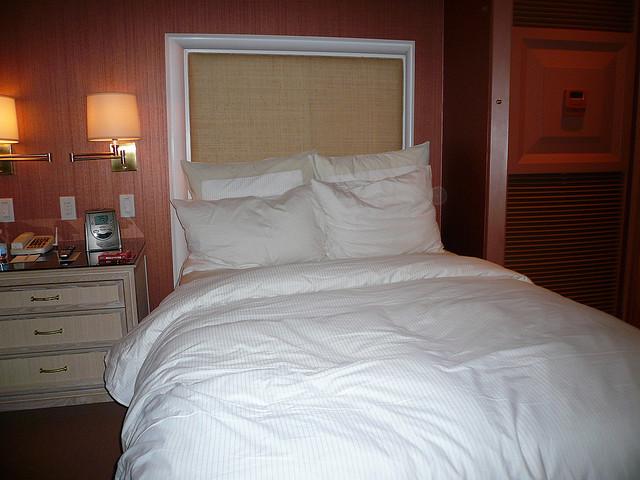Does this bed need to be made?
Answer briefly. No. How many non-white pillows are on the bed?
Write a very short answer. 0. How many pillows are there?
Quick response, please. 4. Are the blinds open in this room?
Quick response, please. No. Is anybody in the bed?
Concise answer only. No. Are all the lamps on?
Short answer required. Yes. Is this bed made?
Quick response, please. Yes. How many lamps are in the picture?
Answer briefly. 2. Is the lamp on?
Be succinct. Yes. Is the bedspread patterned?
Concise answer only. No. What color are the lampshades?
Quick response, please. White. How many pillows are on the bed?
Short answer required. 4. What color is the bedspread?
Answer briefly. White. Is the bed made?
Give a very brief answer. Yes. 